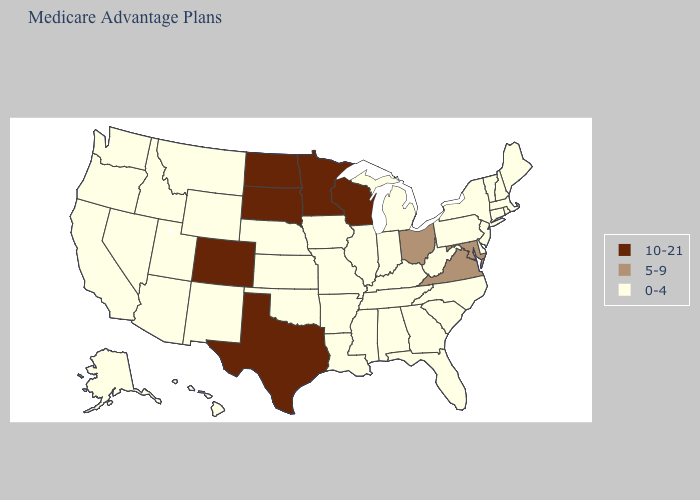Among the states that border Iowa , which have the lowest value?
Quick response, please. Illinois, Missouri, Nebraska. Among the states that border Massachusetts , which have the lowest value?
Answer briefly. Connecticut, New Hampshire, New York, Rhode Island, Vermont. Name the states that have a value in the range 10-21?
Answer briefly. Colorado, Minnesota, North Dakota, South Dakota, Texas, Wisconsin. Does Alabama have the same value as Iowa?
Give a very brief answer. Yes. Does West Virginia have the highest value in the USA?
Answer briefly. No. What is the value of New Mexico?
Answer briefly. 0-4. Name the states that have a value in the range 5-9?
Keep it brief. Maryland, Ohio, Virginia. What is the value of Michigan?
Answer briefly. 0-4. What is the value of New Jersey?
Write a very short answer. 0-4. How many symbols are there in the legend?
Give a very brief answer. 3. What is the value of Wisconsin?
Concise answer only. 10-21. What is the value of Mississippi?
Keep it brief. 0-4. How many symbols are there in the legend?
Keep it brief. 3. What is the value of Connecticut?
Give a very brief answer. 0-4. Name the states that have a value in the range 0-4?
Answer briefly. Alaska, Alabama, Arkansas, Arizona, California, Connecticut, Delaware, Florida, Georgia, Hawaii, Iowa, Idaho, Illinois, Indiana, Kansas, Kentucky, Louisiana, Massachusetts, Maine, Michigan, Missouri, Mississippi, Montana, North Carolina, Nebraska, New Hampshire, New Jersey, New Mexico, Nevada, New York, Oklahoma, Oregon, Pennsylvania, Rhode Island, South Carolina, Tennessee, Utah, Vermont, Washington, West Virginia, Wyoming. 